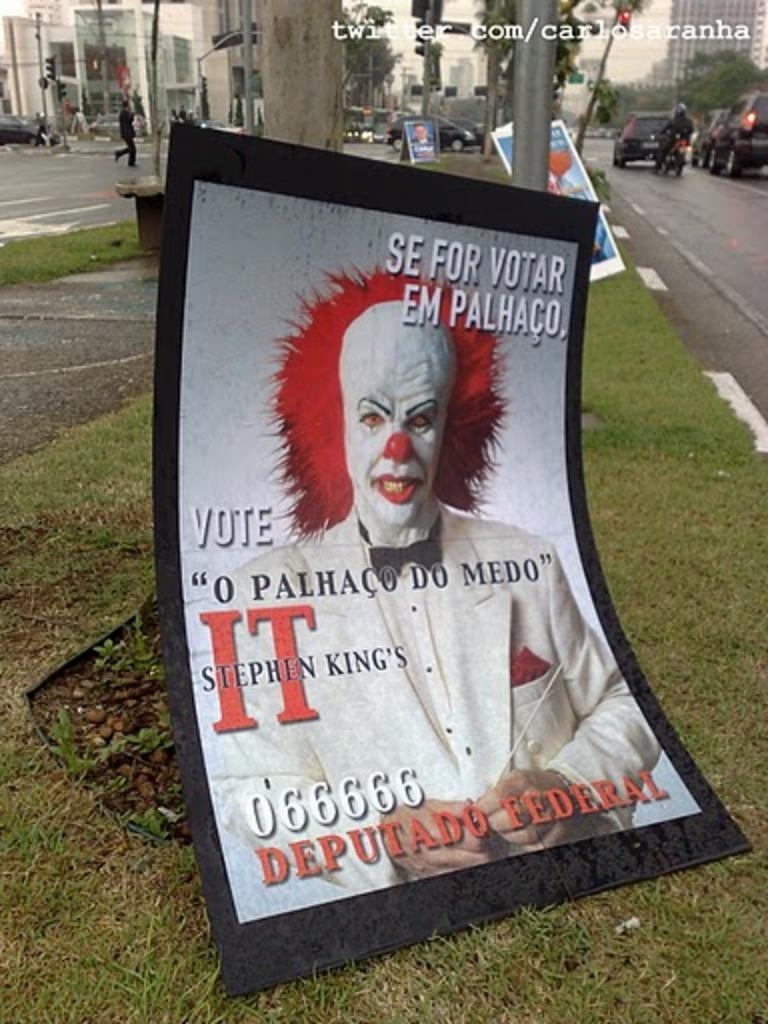<image>
Share a concise interpretation of the image provided. a poster for Stephen King's movie IT being scary 